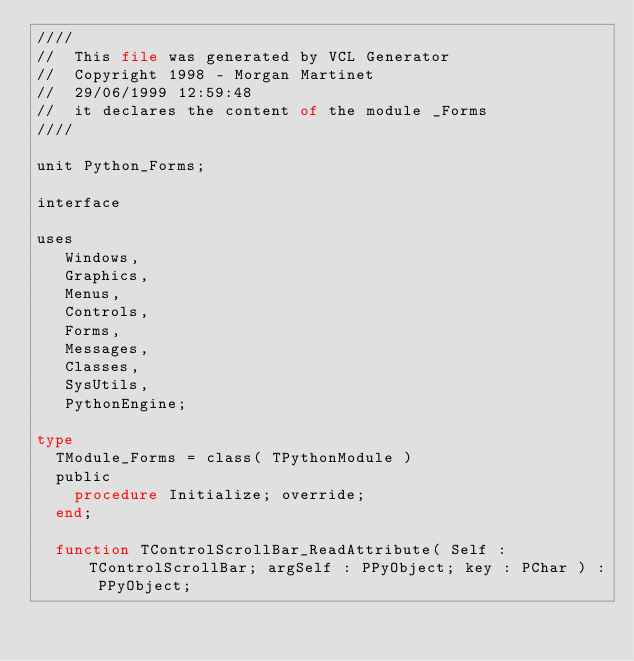<code> <loc_0><loc_0><loc_500><loc_500><_Pascal_>////
//  This file was generated by VCL Generator
//  Copyright 1998 - Morgan Martinet
//  29/06/1999 12:59:48
//  it declares the content of the module _Forms
////

unit Python_Forms;

interface

uses
   Windows,
   Graphics,
   Menus,
   Controls,
   Forms,
   Messages,
   Classes,
   SysUtils,
   PythonEngine;

type
  TModule_Forms = class( TPythonModule )
  public
    procedure Initialize; override;
  end;

  function TControlScrollBar_ReadAttribute( Self : TControlScrollBar; argSelf : PPyObject; key : PChar ) : PPyObject;</code> 